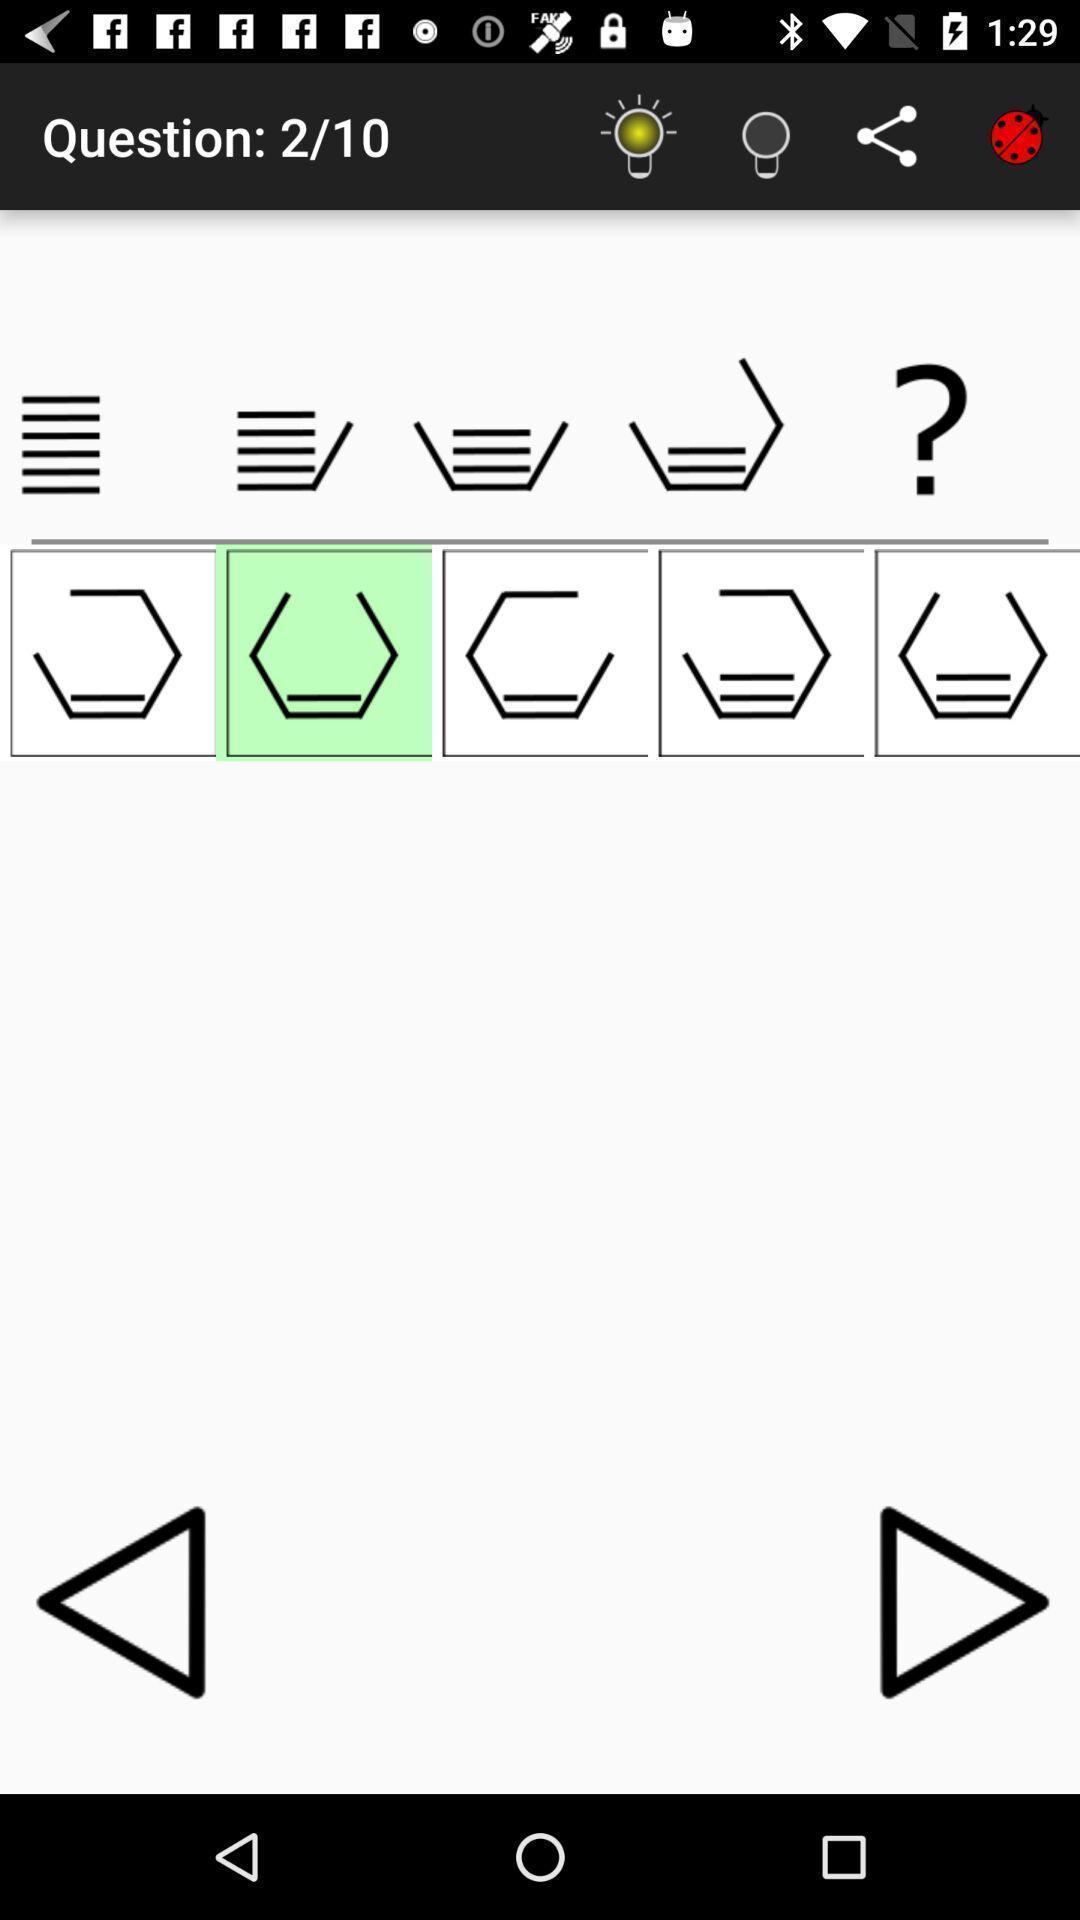Explain what's happening in this screen capture. Question page of an aptitude test app. 